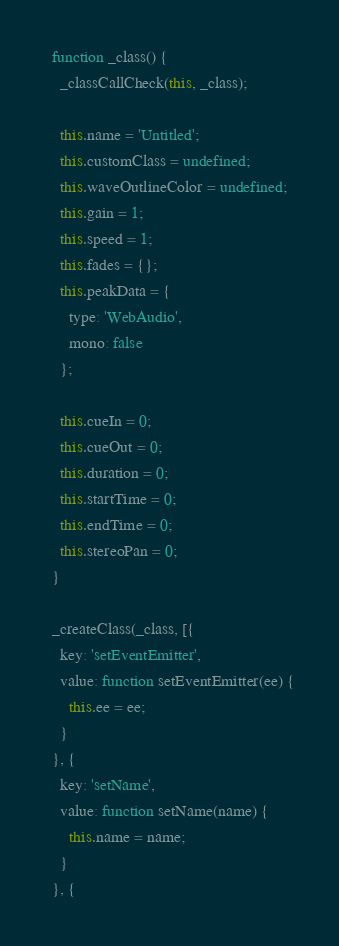<code> <loc_0><loc_0><loc_500><loc_500><_JavaScript_>  function _class() {
    _classCallCheck(this, _class);

    this.name = 'Untitled';
    this.customClass = undefined;
    this.waveOutlineColor = undefined;
    this.gain = 1;
    this.speed = 1;
    this.fades = {};
    this.peakData = {
      type: 'WebAudio',
      mono: false
    };

    this.cueIn = 0;
    this.cueOut = 0;
    this.duration = 0;
    this.startTime = 0;
    this.endTime = 0;
    this.stereoPan = 0;
  }

  _createClass(_class, [{
    key: 'setEventEmitter',
    value: function setEventEmitter(ee) {
      this.ee = ee;
    }
  }, {
    key: 'setName',
    value: function setName(name) {
      this.name = name;
    }
  }, {</code> 